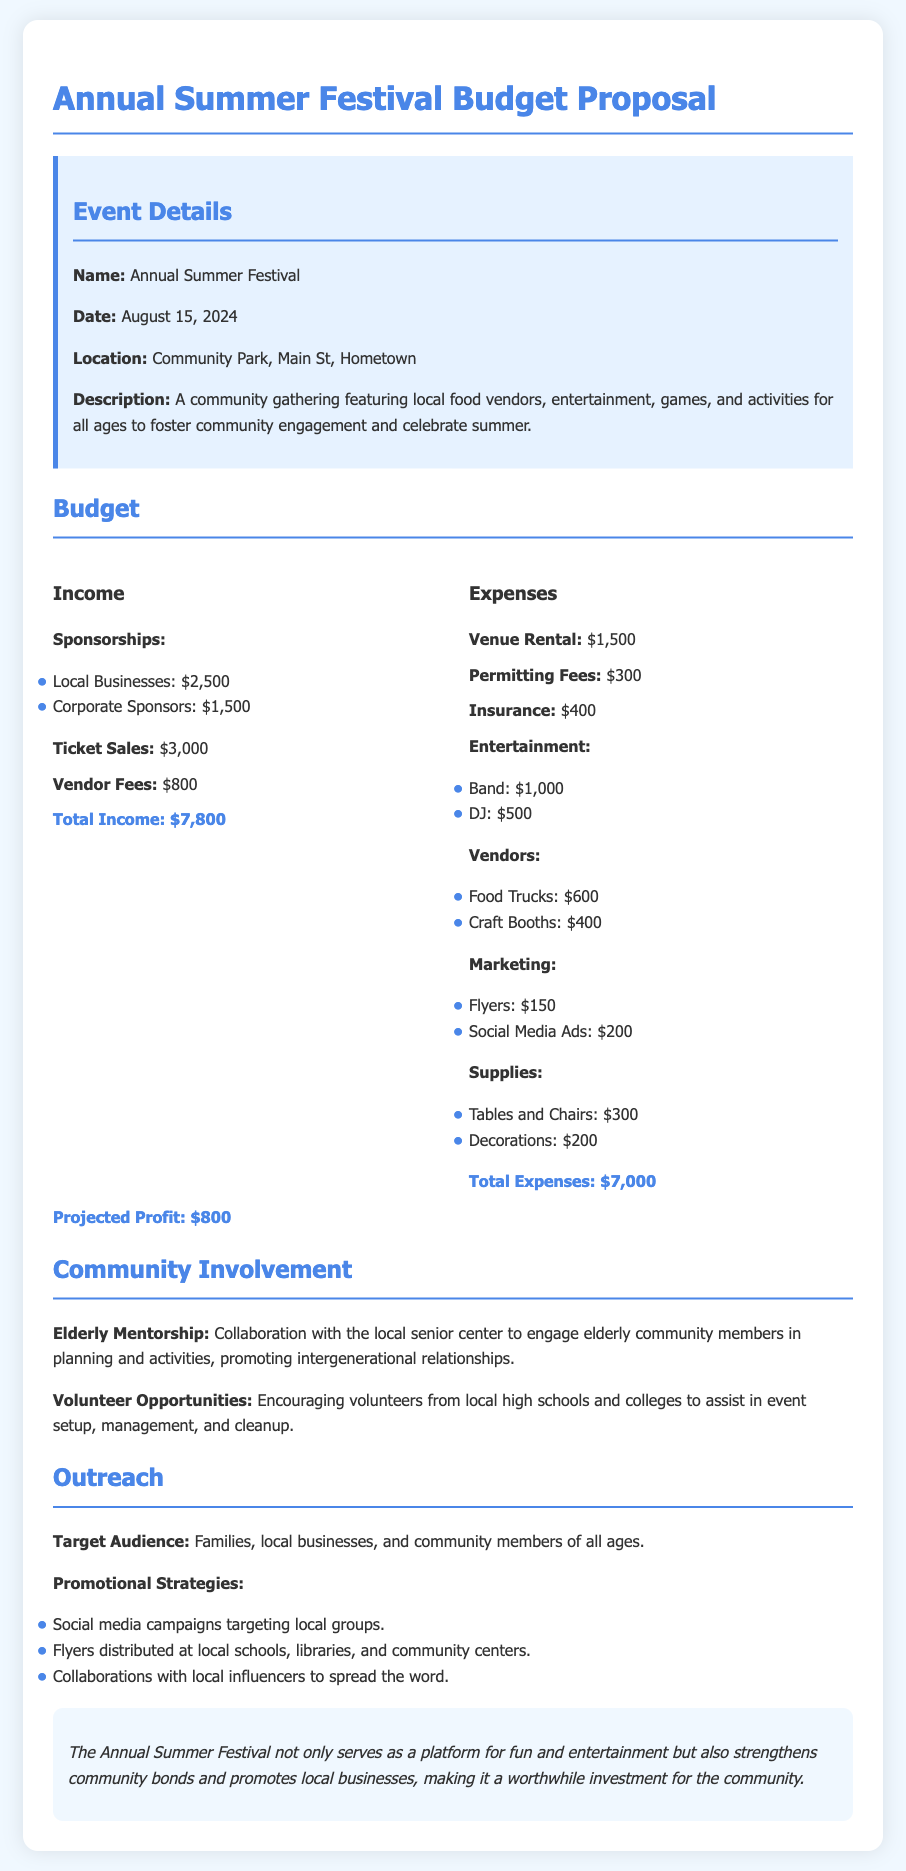What is the name of the event? The document specifies the name of the event as the “Annual Summer Festival.”
Answer: Annual Summer Festival What is the date of the festival? The date listed in the document for the festival is August 15, 2024.
Answer: August 15, 2024 What is the total income projected? The total income is provided as the sum of various sources, totaling $7,800.
Answer: $7,800 What are the total expenses for the event? The document states that the total expenses amount to $7,000.
Answer: $7,000 What is the projected profit from the festival? According to the document, the projected profit is $800.
Answer: $800 Where is the festival located? The location for the festival is mentioned as Community Park, Main St, Hometown.
Answer: Community Park, Main St, Hometown How much is allocated for the Band under entertainment? The document indicates that the cost for the Band is $1,000.
Answer: $1,000 What is the marketing budget for flyers? The budget for flyers specifically mentioned in the document is $150.
Answer: $150 How are elderly community members involved in the festival? The document indicates that there is a collaboration with the local senior center for planning activities with elderly community members.
Answer: Collaboration with the local senior center 